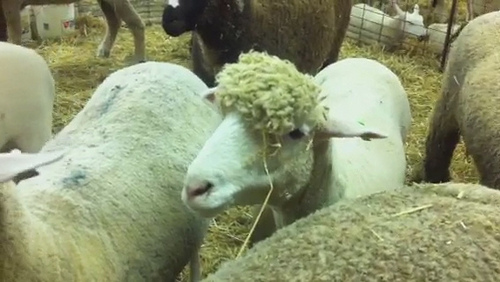Imagine if the pen was enchanted. What magical features would it have? In an enchanted pen, the hay would glow with a gentle golden light, and the fence would be made of shimmering silver vines that softly hum with ancient magic. The sheep would have wool that sparkles in the sunlight, and flowers would bloom under their hooves wherever they stepped. An aura of peace and tranquility would pervade the air, and a wise old owl might preside over the pen, offering sage advice to visitors. 